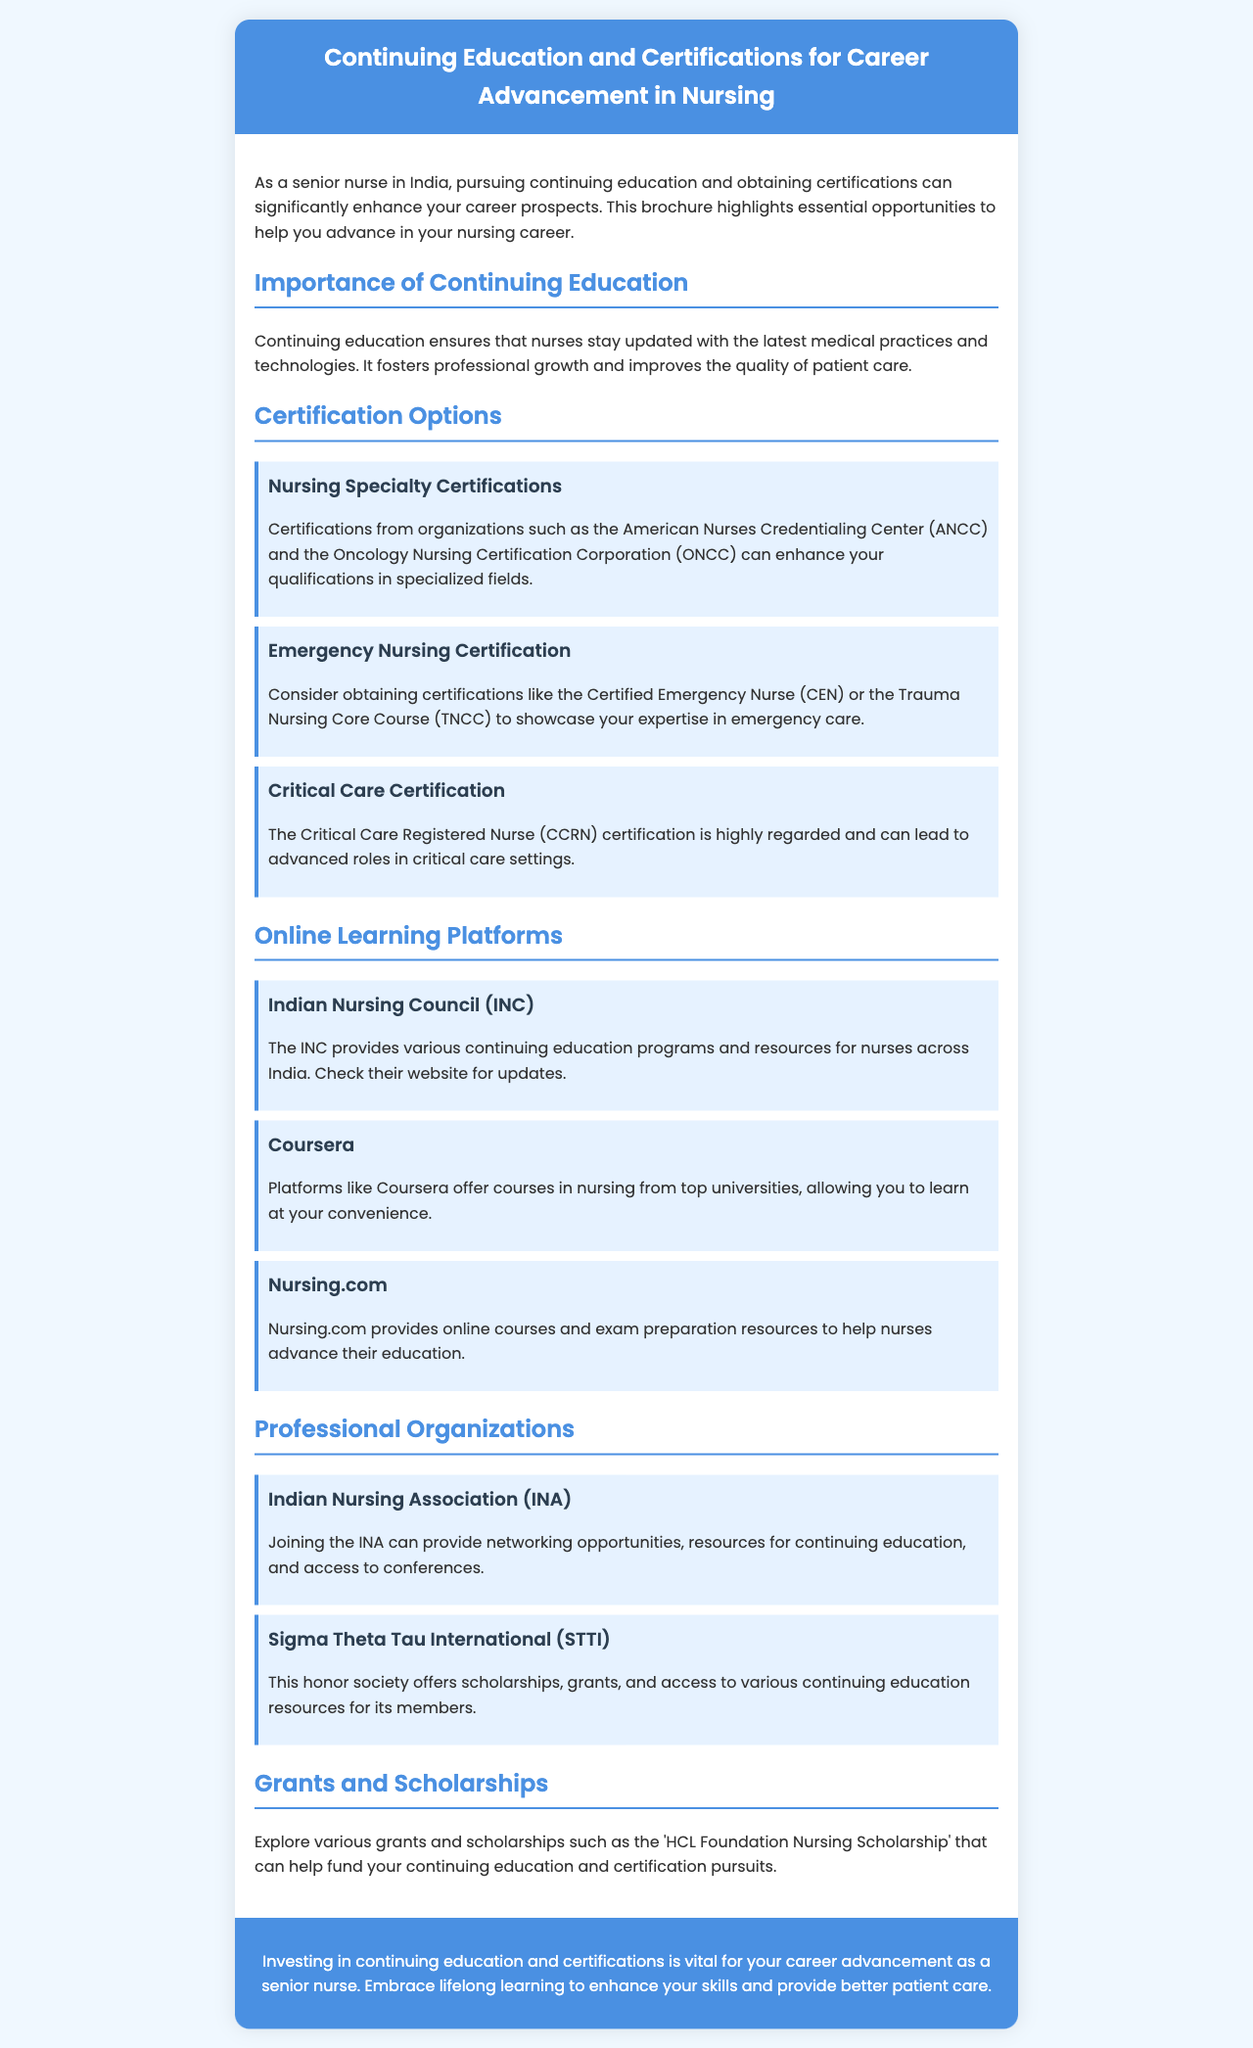what is the main topic of the brochure? The main topic of the brochure focuses on continuing education and certifications in nursing.
Answer: Continuing Education and Certifications for Career Advancement in Nursing who offers the Critical Care Registered Nurse certification? The certification is associated with advanced roles in critical care settings; ANCC and ONCC are mentioned for various specialties.
Answer: ANCC and ONCC which online platform provides nursing courses from top universities? The brochure lists platforms for online learning; one specifically offers courses from universities.
Answer: Coursera name one organization that provides networking opportunities for nurses in India. The document states the benefits of joining professional organizations for nurses.
Answer: Indian Nursing Association (INA) what type of certification should a nurse consider for emergency care? The brochure recommends specific certifications related to emergency nursing.
Answer: Certified Emergency Nurse (CEN) how many online learning platforms are mentioned in the document? The section on online platforms lists three different options for continuing education.
Answer: Three what is the purpose of continuing education according to the brochure? The document highlights the role of continuing education in professional growth and patient care.
Answer: Professional growth which scholarship can help fund continuing education for nurses? The brochure mentions various grants and scholarships available to support further education and certifications.
Answer: HCL Foundation Nursing Scholarship 